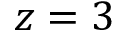<formula> <loc_0><loc_0><loc_500><loc_500>z = 3</formula> 